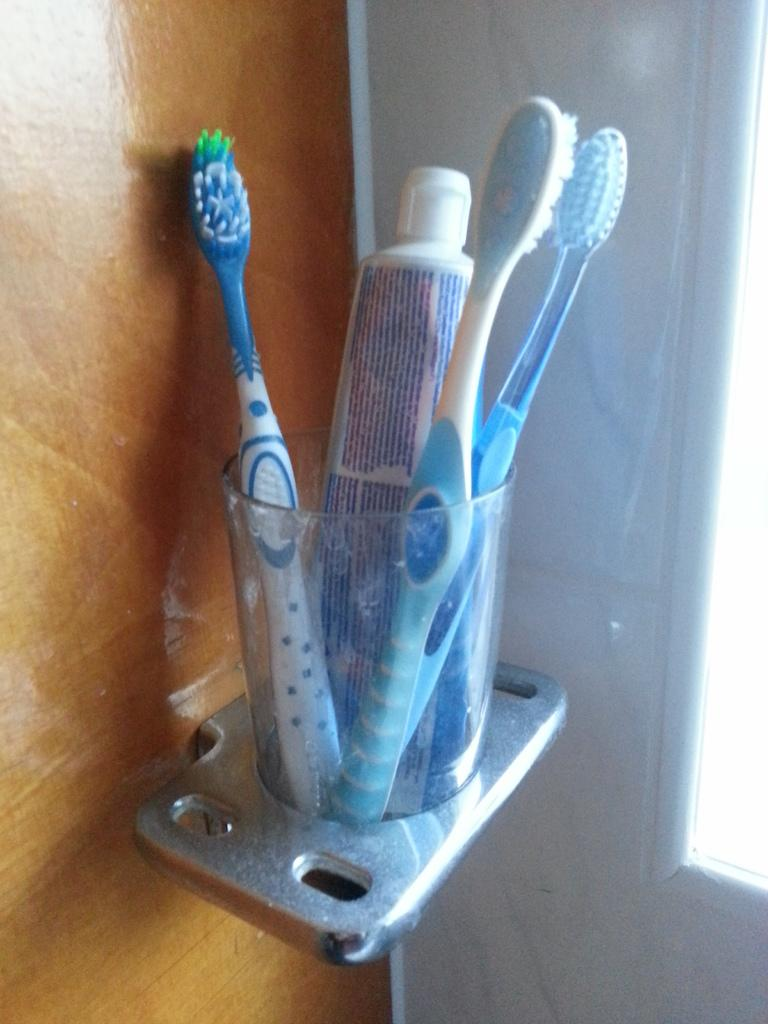What objects are in the image that are used for applying paste? There are brushes in the image that are used for applying paste. What substance is used with the brushes in the image? There is paste in the image that is used with the brushes. Where are the brushes and paste located in the image? The brushes and paste are in a holder in the image. What can be seen in the background of the image? There is a wall in the image that can be seen in the background. Reasoning: Let' Let's think step by step in order to produce the conversation. We start by identifying the main objects in the image, which are the brushes and paste. Then, we describe their purpose and how they are stored. Finally, we mention the background element, which is the wall. Each question is designed to elicit a specific detail about the image that is known from the provided facts. Absurd Question/Answer: What invention is being demonstrated in the image? There is no invention being demonstrated in the image. 